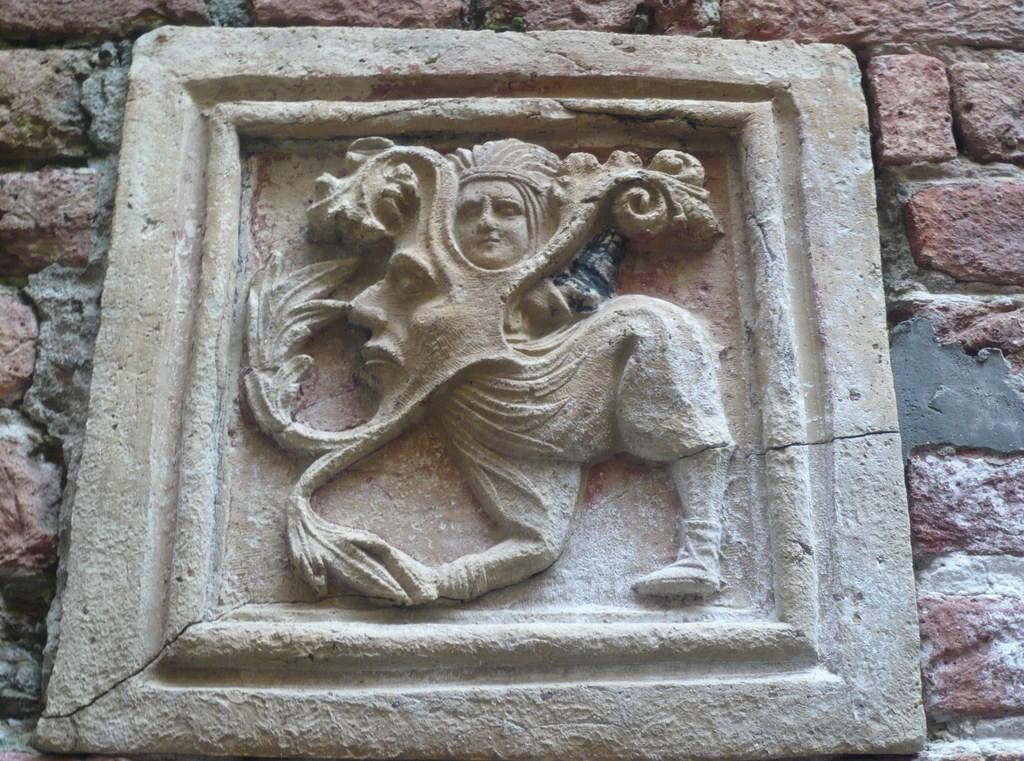What is the main subject of the image? There is a sculpture in the image. Where is the sculpture located? The sculpture is on a brick wall. Are there any cobwebs visible on the sculpture in the image? There is no mention of cobwebs in the provided facts, so we cannot determine if any are present in the image. 